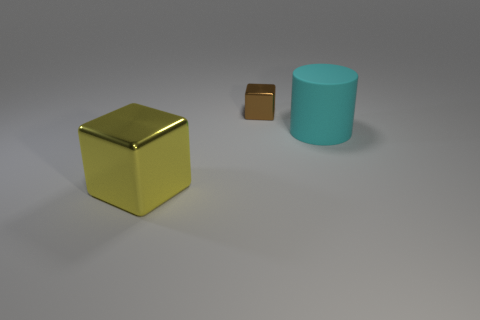The cyan thing that is the same size as the yellow object is what shape?
Provide a succinct answer. Cylinder. There is a large shiny cube; are there any rubber cylinders in front of it?
Offer a very short reply. No. Is the cylinder the same size as the yellow object?
Your answer should be very brief. Yes. What shape is the shiny thing behind the large matte object?
Offer a terse response. Cube. Is there a cyan thing of the same size as the yellow metallic object?
Offer a very short reply. Yes. There is a yellow cube that is the same size as the cyan matte object; what material is it?
Provide a short and direct response. Metal. What is the size of the cube behind the big cyan cylinder?
Provide a short and direct response. Small. How big is the yellow block?
Your response must be concise. Large. There is a brown metallic object; is it the same size as the cyan matte cylinder that is behind the big yellow object?
Your response must be concise. No. The metal thing on the right side of the cube that is in front of the tiny brown thing is what color?
Give a very brief answer. Brown. 